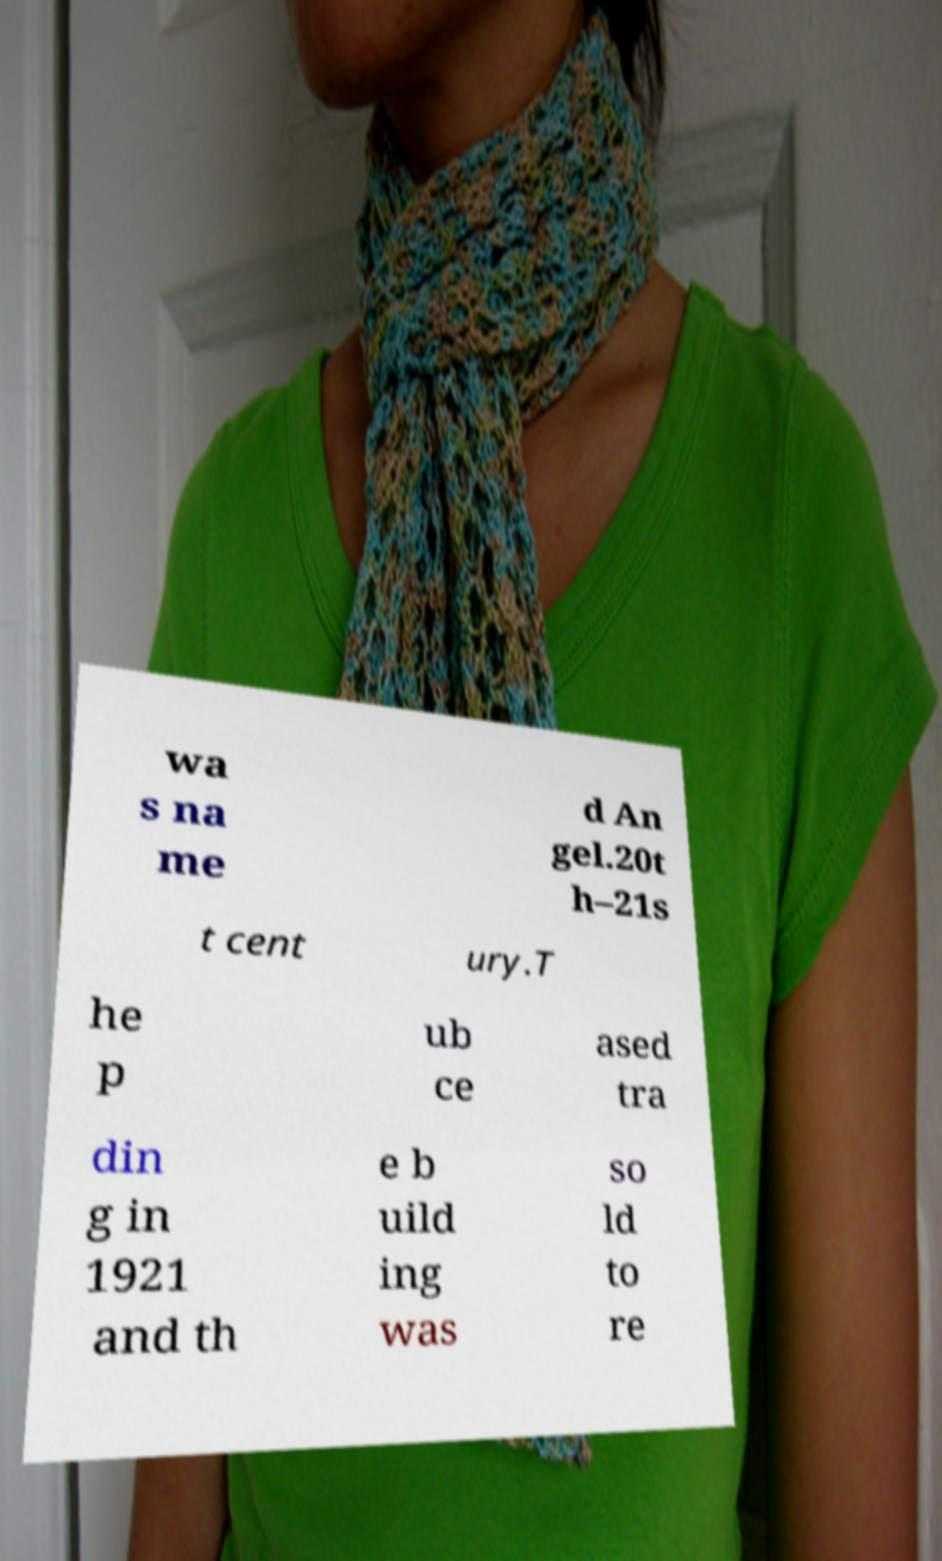Please read and relay the text visible in this image. What does it say? wa s na me d An gel.20t h–21s t cent ury.T he p ub ce ased tra din g in 1921 and th e b uild ing was so ld to re 